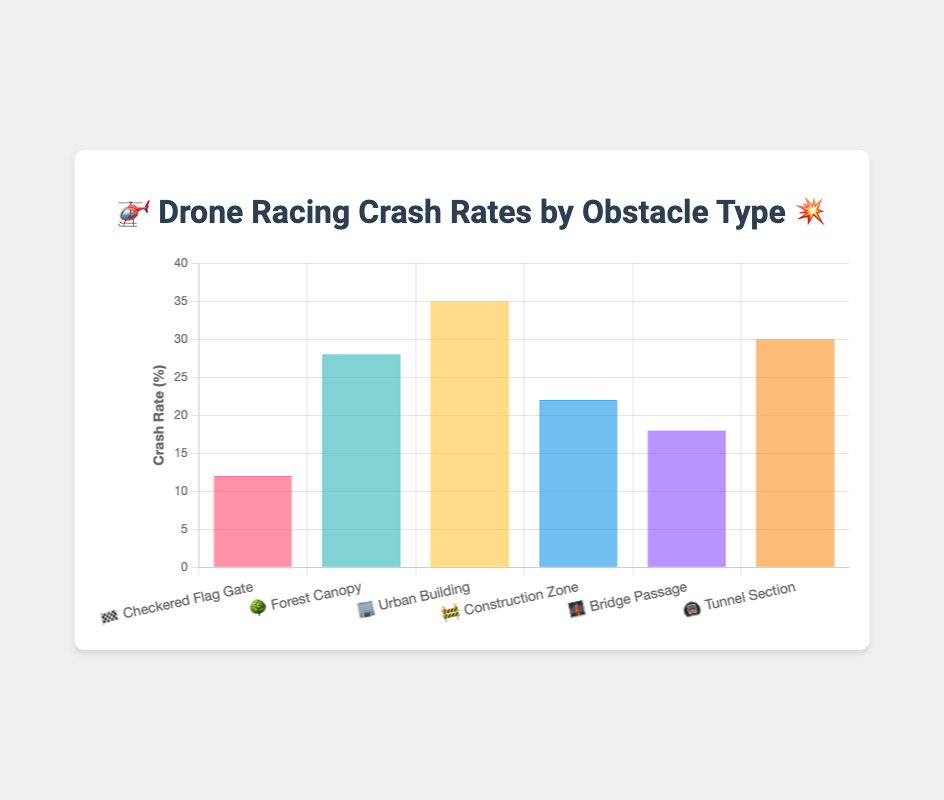Which obstacle type has the highest crash rate? By looking at the bar with the tallest height, we can see that the "🏢 Urban Building" obstacle has the highest crash rate, indicated by a value of 35%.
Answer: Urban Building What is the crash rate for the "🌉 Bridge Passage" obstacle? By referring to the bar labeled "🌉 Bridge Passage," we see the value associated with it is 18%.
Answer: 18% How many obstacle types have a crash rate above 25%? By evaluating each bar, the obstacle types "🌳 Forest Canopy," "🏢 Urban Building," and "🚇 Tunnel Section" all have crash rates above 25%. This results in a total of 3 obstacle types.
Answer: 3 What is the difference in crash rate between the "🏁 Checkered Flag Gate" and "🚧 Construction Zone" obstacles? The crash rate for "🏁 Checkered Flag Gate" is 12%, while the crash rate for "🚧 Construction Zone" is 22%. The difference is calculated as 22% - 12% = 10%.
Answer: 10% Which obstacle type is indicated by the emoji "🍃"? By aligning the indices of "emoji_indicators" and "obstacle_types," the emoji "🍃" corresponds to "🌳 Forest Canopy."
Answer: Forest Canopy What is the average crash rate across all obstacle types? Sum the crash rates (12% + 28% + 35% + 22% + 18% + 30%) and divide by the number of obstacles (6). The total is 145%, so the average is 145% / 6 ≈ 24.17%.
Answer: 24.17% How does the crash rate of the "🚇 Tunnel Section" compare to the "🌳 Forest Canopy"? The "🚇 Tunnel Section" has a crash rate of 30%, while "🌳 Forest Canopy" has a crash rate of 28%. The "🚇 Tunnel Section" rate is higher by 2%.
Answer: 2% What is the median crash rate of all the obstacles? To find the median, list the crash rates in ascending order: 12%, 18%, 22%, 28%, 30%, 35%. The median is the average of the middle two values (22% and 28%), so (22% + 28%) / 2 = 25%.
Answer: 25% Which color represents the "🏢 Urban Building" obstacle in the chart? The "🏢 Urban Building" is the third obstacle from the left, represented by a yellow shade in the chart.
Answer: Yellow 